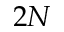<formula> <loc_0><loc_0><loc_500><loc_500>2 N</formula> 